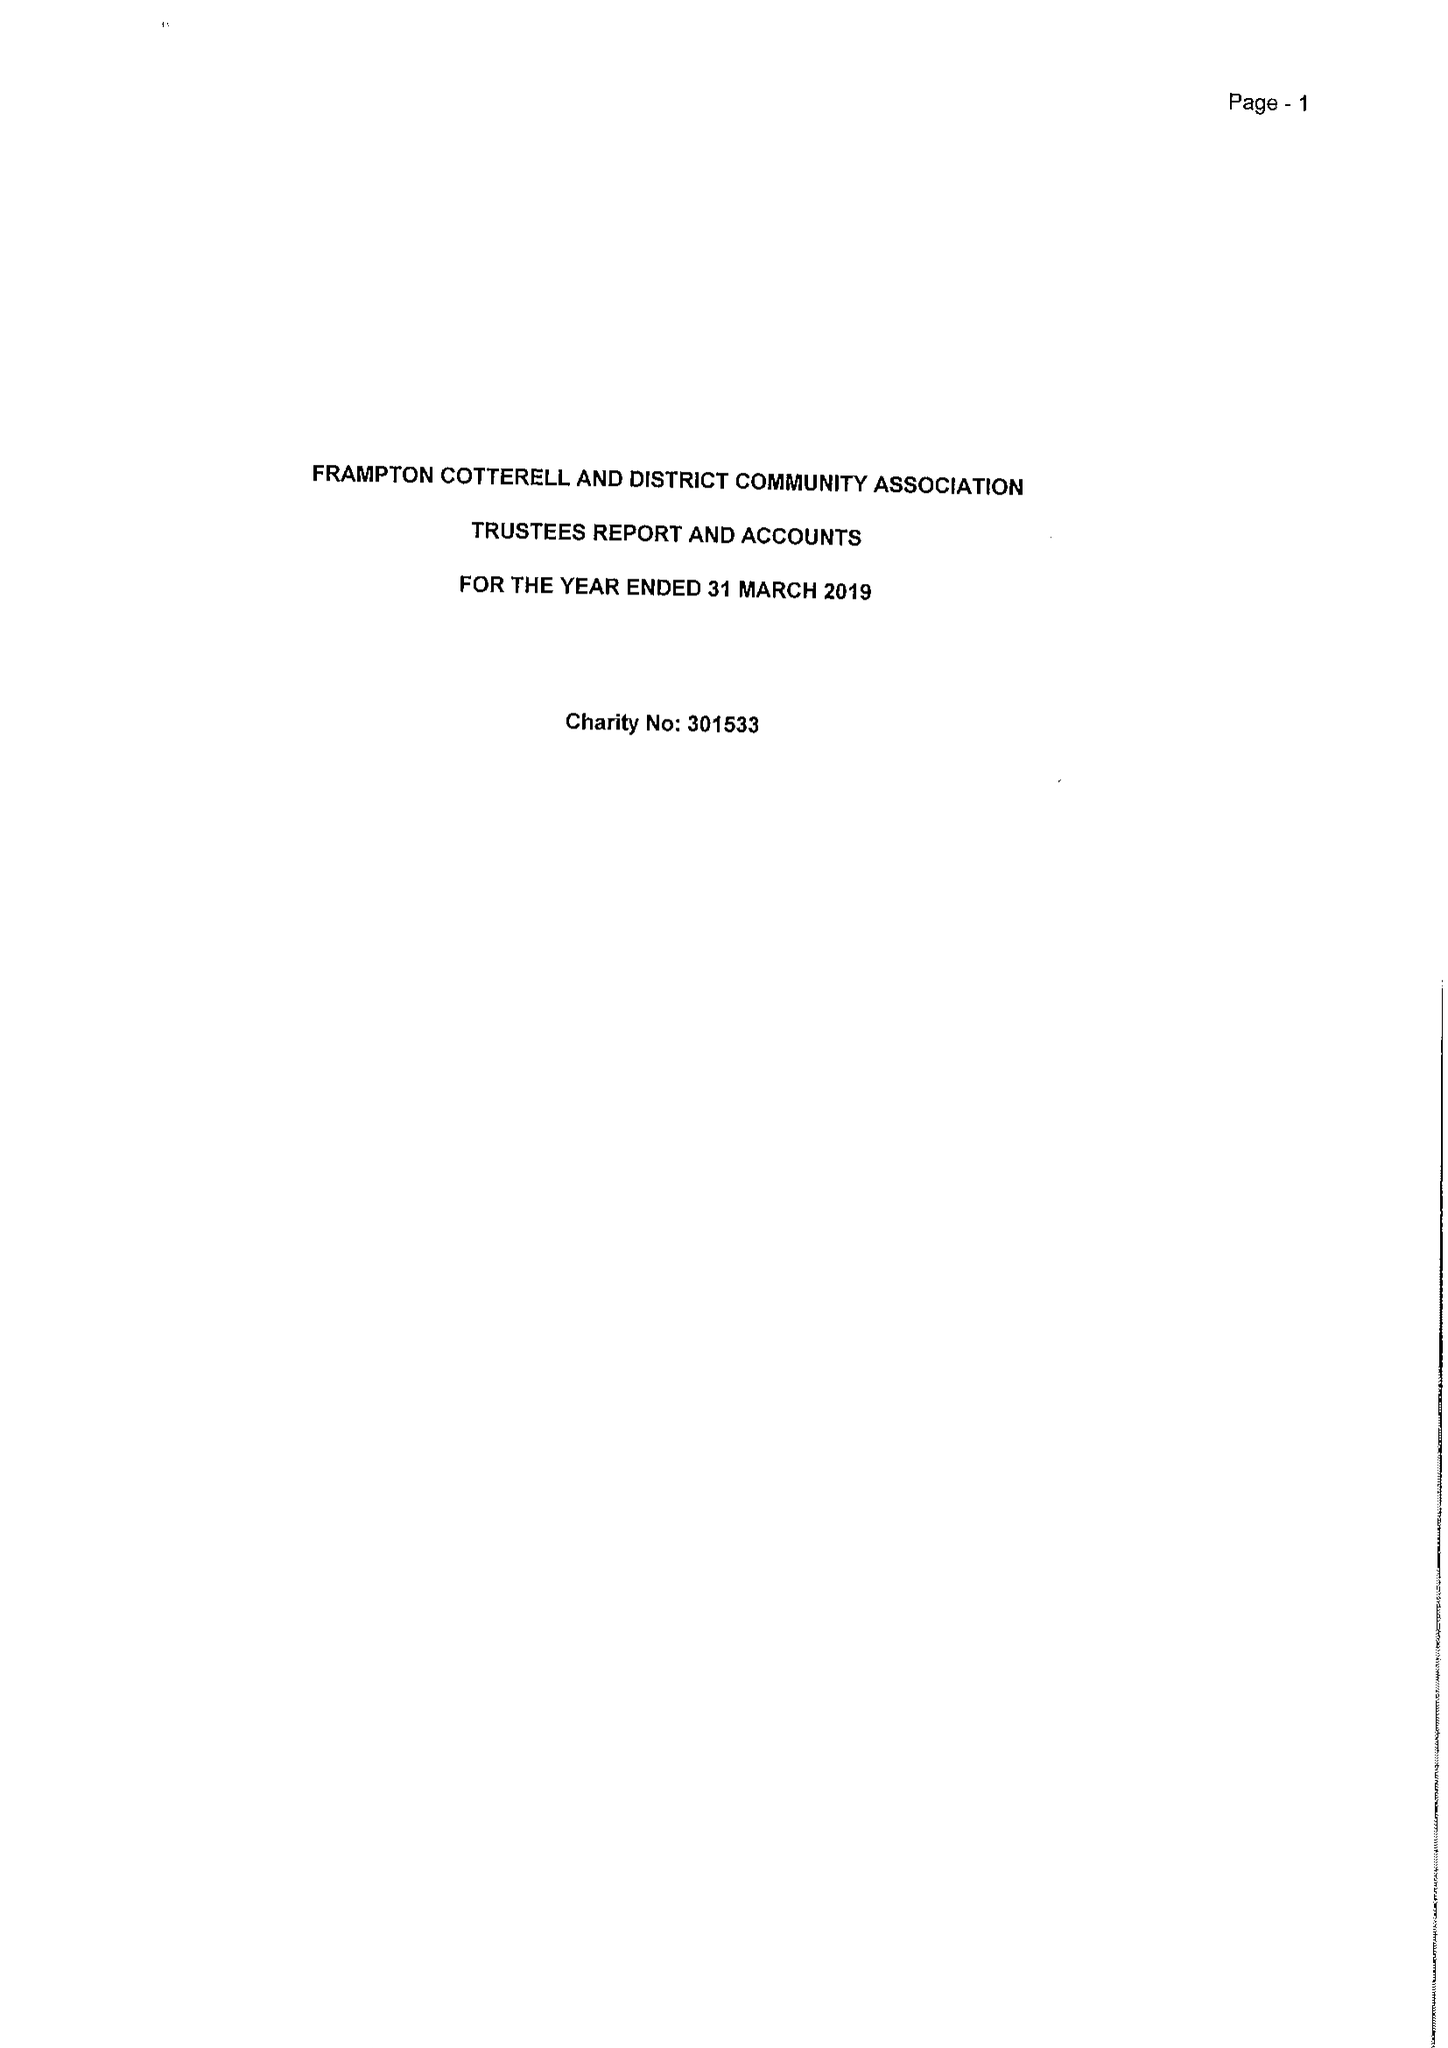What is the value for the address__post_town?
Answer the question using a single word or phrase. BRISTOL 